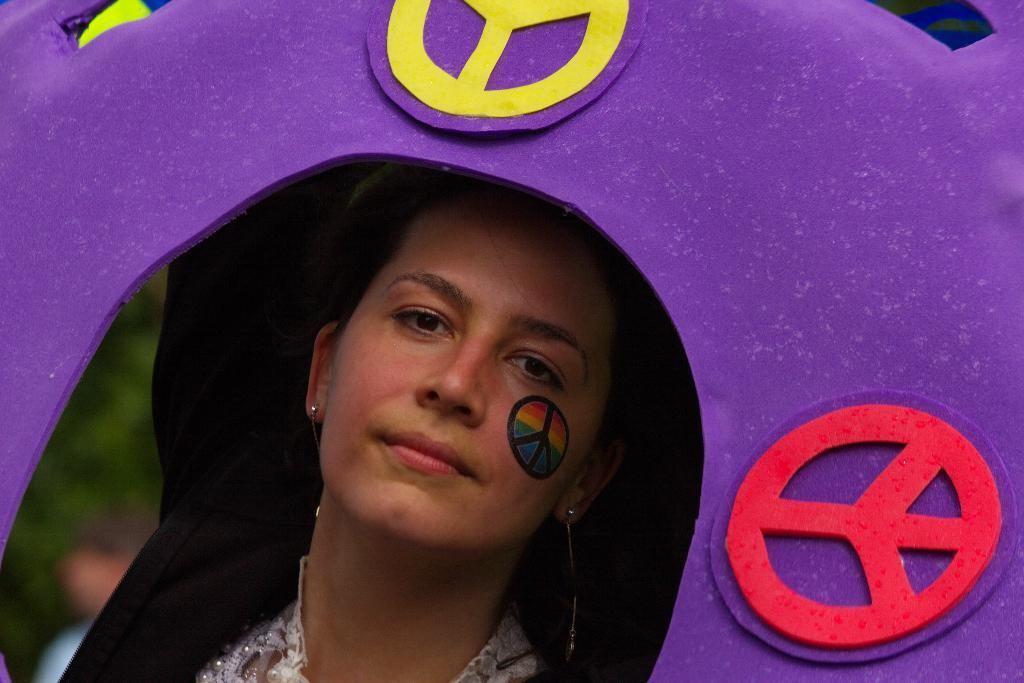Where was the image taken? The image is taken outdoors. What can be seen in the middle of the image? There is a woman in a cave in the middle of the image. Can you describe the background of the image? There is a person and a tree in the background of the image. What time of day is it in the image? The provided facts do not mention the time of day, so it cannot be determined from the image. 